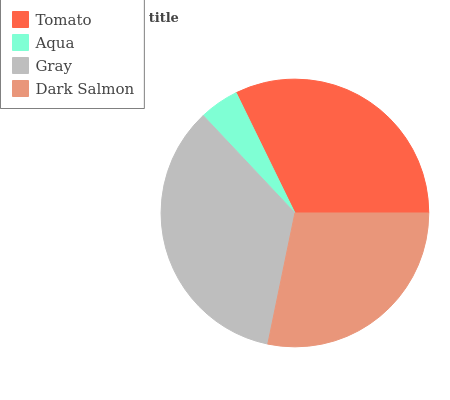Is Aqua the minimum?
Answer yes or no. Yes. Is Gray the maximum?
Answer yes or no. Yes. Is Gray the minimum?
Answer yes or no. No. Is Aqua the maximum?
Answer yes or no. No. Is Gray greater than Aqua?
Answer yes or no. Yes. Is Aqua less than Gray?
Answer yes or no. Yes. Is Aqua greater than Gray?
Answer yes or no. No. Is Gray less than Aqua?
Answer yes or no. No. Is Tomato the high median?
Answer yes or no. Yes. Is Dark Salmon the low median?
Answer yes or no. Yes. Is Gray the high median?
Answer yes or no. No. Is Aqua the low median?
Answer yes or no. No. 